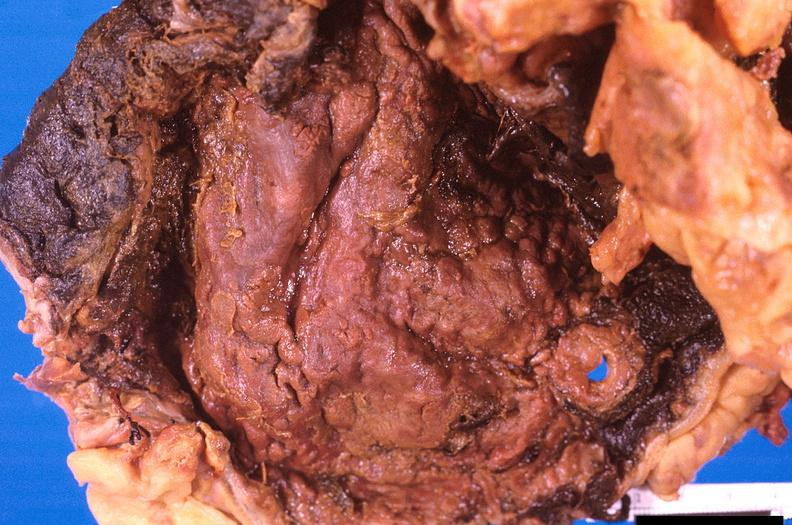does this image show stomach, necrotizing esophagitis and gastritis, sulfuric acid ingested as suicide attempt?
Answer the question using a single word or phrase. Yes 